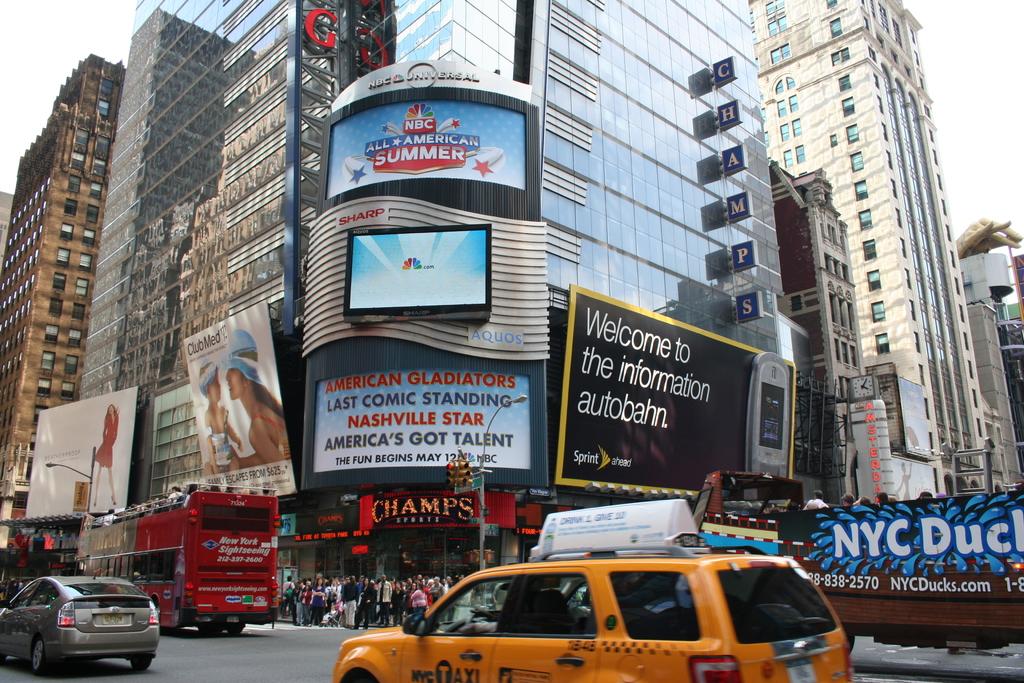What is the name of the sports store?
Your answer should be compact. Champs. What is the sprint slogan on the big black board?
Give a very brief answer. Welcome to the information autobahn. 